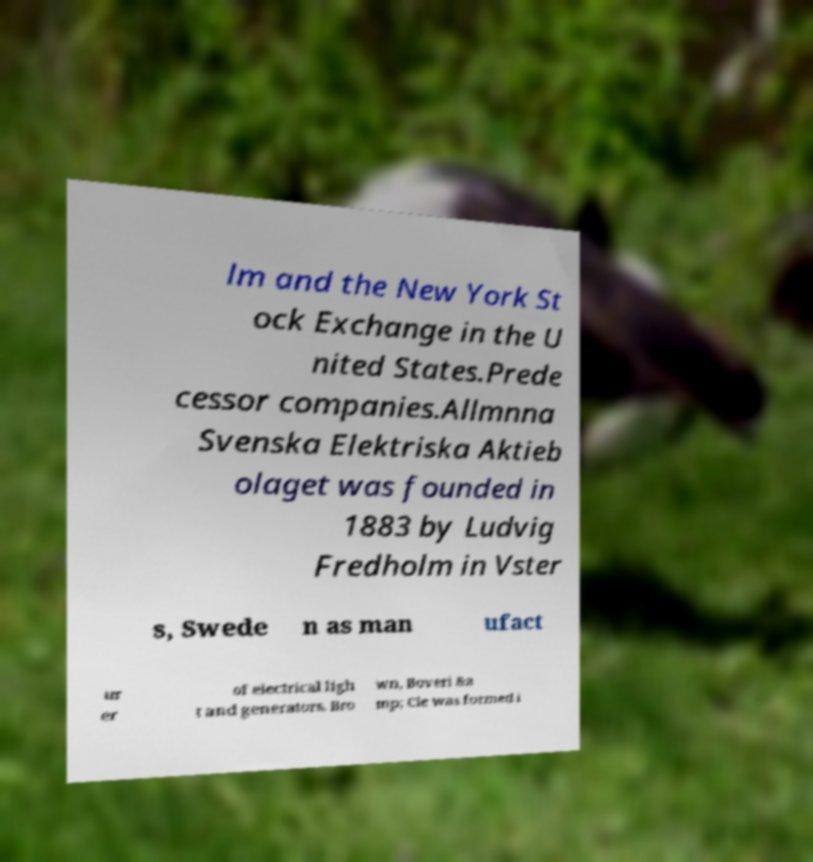What messages or text are displayed in this image? I need them in a readable, typed format. lm and the New York St ock Exchange in the U nited States.Prede cessor companies.Allmnna Svenska Elektriska Aktieb olaget was founded in 1883 by Ludvig Fredholm in Vster s, Swede n as man ufact ur er of electrical ligh t and generators. Bro wn, Boveri &a mp; Cie was formed i 